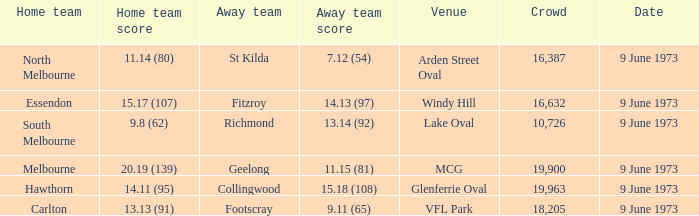Could you parse the entire table as a dict? {'header': ['Home team', 'Home team score', 'Away team', 'Away team score', 'Venue', 'Crowd', 'Date'], 'rows': [['North Melbourne', '11.14 (80)', 'St Kilda', '7.12 (54)', 'Arden Street Oval', '16,387', '9 June 1973'], ['Essendon', '15.17 (107)', 'Fitzroy', '14.13 (97)', 'Windy Hill', '16,632', '9 June 1973'], ['South Melbourne', '9.8 (62)', 'Richmond', '13.14 (92)', 'Lake Oval', '10,726', '9 June 1973'], ['Melbourne', '20.19 (139)', 'Geelong', '11.15 (81)', 'MCG', '19,900', '9 June 1973'], ['Hawthorn', '14.11 (95)', 'Collingwood', '15.18 (108)', 'Glenferrie Oval', '19,963', '9 June 1973'], ['Carlton', '13.13 (91)', 'Footscray', '9.11 (65)', 'VFL Park', '18,205', '9 June 1973']]} Where did Fitzroy play as the away team? Windy Hill. 